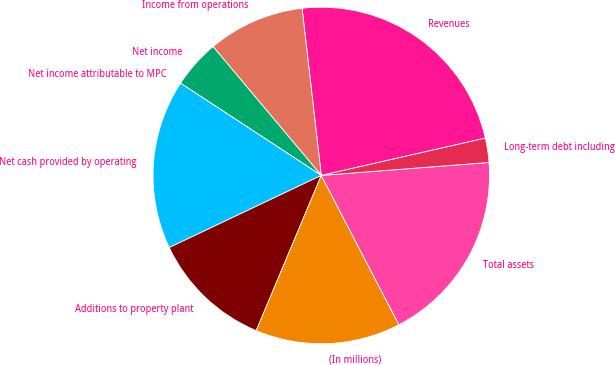Convert chart to OTSL. <chart><loc_0><loc_0><loc_500><loc_500><pie_chart><fcel>Revenues<fcel>Income from operations<fcel>Net income<fcel>Net income attributable to MPC<fcel>Net cash provided by operating<fcel>Additions to property plant<fcel>(In millions)<fcel>Total assets<fcel>Long-term debt including<nl><fcel>23.26%<fcel>9.3%<fcel>4.65%<fcel>0.0%<fcel>16.28%<fcel>11.63%<fcel>13.95%<fcel>18.6%<fcel>2.33%<nl></chart> 